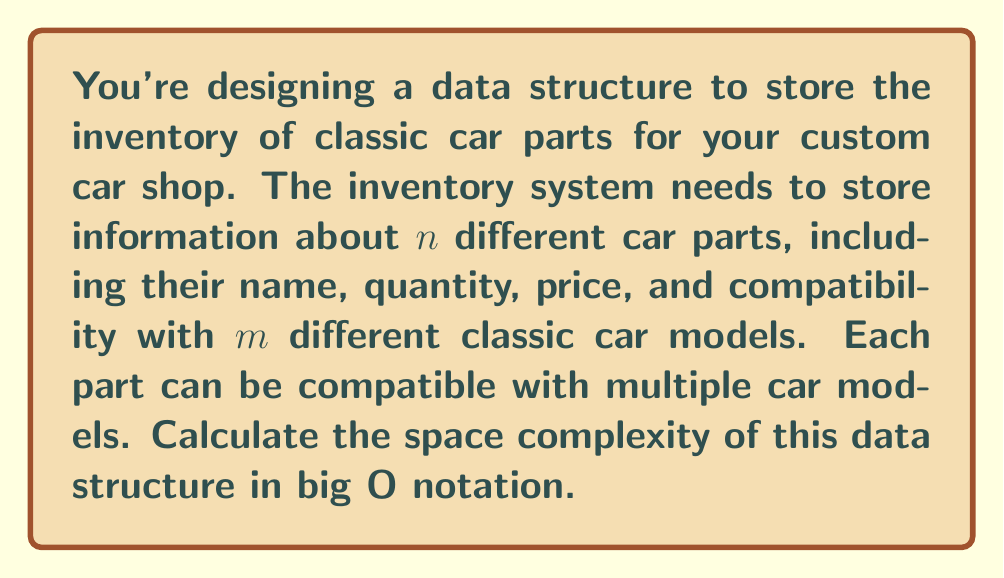Help me with this question. To calculate the space complexity, let's break down the components of our data structure:

1. Part information:
   - Name: Assuming a fixed-length string, this takes $O(1)$ space per part.
   - Quantity: An integer, which takes $O(1)$ space.
   - Price: A floating-point number, also $O(1)$ space.

2. Compatibility information:
   - We need to store compatibility for each part with $m$ car models.
   - This can be represented as a boolean array or a bit vector of length $m$ for each part.
   - The space needed for compatibility is $O(m)$ per part.

Now, let's combine these components:

1. For a single part, we need $O(1)$ space for basic information and $O(m)$ space for compatibility.
   Total space per part: $O(1) + O(m) = O(m)$

2. We have $n$ parts in total, so we multiply the space per part by $n$:
   Total space: $O(m) * n = O(mn)$

Therefore, the overall space complexity of the data structure is $O(mn)$.

This means that the space required grows linearly with both the number of parts and the number of car models. As you expand your inventory or add support for more classic car models, the space requirement will increase proportionally.
Answer: The space complexity of the data structure for storing classic car parts inventory is $O(mn)$, where $n$ is the number of parts and $m$ is the number of classic car models. 